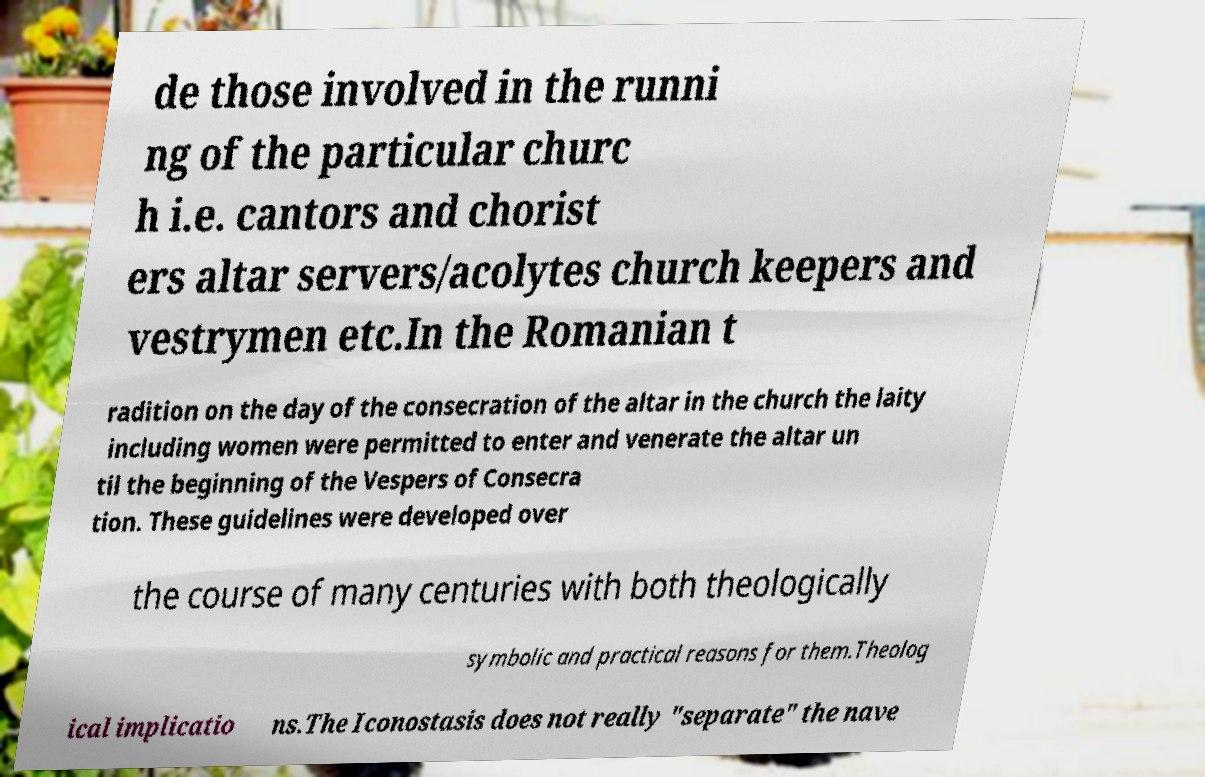Could you assist in decoding the text presented in this image and type it out clearly? de those involved in the runni ng of the particular churc h i.e. cantors and chorist ers altar servers/acolytes church keepers and vestrymen etc.In the Romanian t radition on the day of the consecration of the altar in the church the laity including women were permitted to enter and venerate the altar un til the beginning of the Vespers of Consecra tion. These guidelines were developed over the course of many centuries with both theologically symbolic and practical reasons for them.Theolog ical implicatio ns.The Iconostasis does not really "separate" the nave 